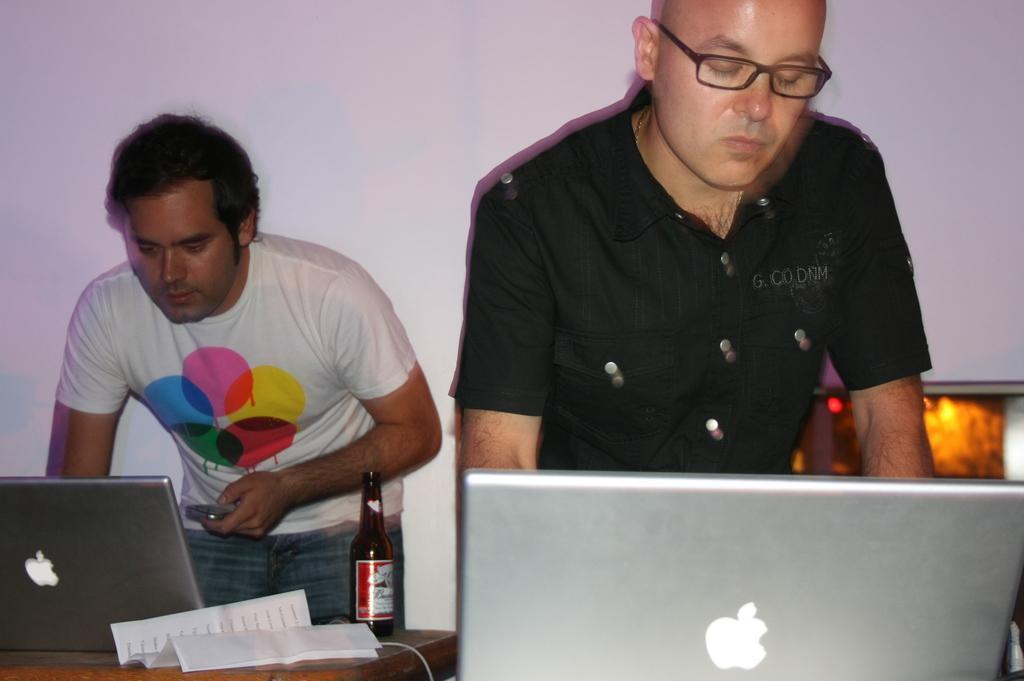In one or two sentences, can you explain what this image depicts? In this picture, There are some laptops which are in ash color and there is a paper on the table there is a wine bottle which is in brown color and there are some people standing, In the background there is a white color wall. 